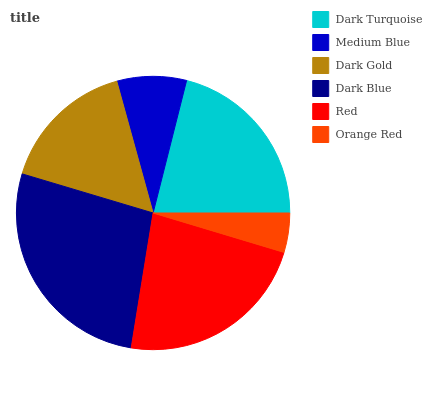Is Orange Red the minimum?
Answer yes or no. Yes. Is Dark Blue the maximum?
Answer yes or no. Yes. Is Medium Blue the minimum?
Answer yes or no. No. Is Medium Blue the maximum?
Answer yes or no. No. Is Dark Turquoise greater than Medium Blue?
Answer yes or no. Yes. Is Medium Blue less than Dark Turquoise?
Answer yes or no. Yes. Is Medium Blue greater than Dark Turquoise?
Answer yes or no. No. Is Dark Turquoise less than Medium Blue?
Answer yes or no. No. Is Dark Turquoise the high median?
Answer yes or no. Yes. Is Dark Gold the low median?
Answer yes or no. Yes. Is Dark Gold the high median?
Answer yes or no. No. Is Dark Blue the low median?
Answer yes or no. No. 